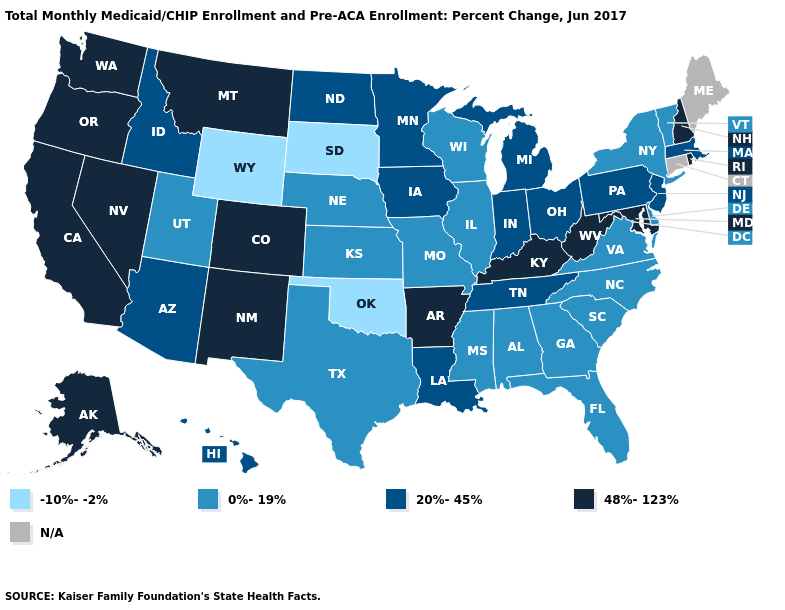What is the value of New Mexico?
Short answer required. 48%-123%. How many symbols are there in the legend?
Write a very short answer. 5. Among the states that border Connecticut , does Rhode Island have the highest value?
Give a very brief answer. Yes. Does New Jersey have the highest value in the USA?
Concise answer only. No. Does the map have missing data?
Write a very short answer. Yes. Does New York have the lowest value in the Northeast?
Keep it brief. Yes. Which states have the lowest value in the Northeast?
Write a very short answer. New York, Vermont. How many symbols are there in the legend?
Short answer required. 5. Name the states that have a value in the range 20%-45%?
Give a very brief answer. Arizona, Hawaii, Idaho, Indiana, Iowa, Louisiana, Massachusetts, Michigan, Minnesota, New Jersey, North Dakota, Ohio, Pennsylvania, Tennessee. What is the value of Missouri?
Answer briefly. 0%-19%. What is the value of Utah?
Answer briefly. 0%-19%. Name the states that have a value in the range N/A?
Answer briefly. Connecticut, Maine. Which states have the lowest value in the USA?
Write a very short answer. Oklahoma, South Dakota, Wyoming. 